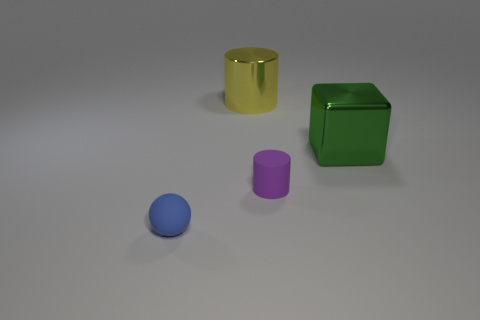Subtract 0 brown blocks. How many objects are left? 4 Subtract all cubes. How many objects are left? 3 Subtract all purple blocks. Subtract all blue balls. How many blocks are left? 1 Subtract all green balls. How many yellow cylinders are left? 1 Subtract all big red spheres. Subtract all tiny matte objects. How many objects are left? 2 Add 1 yellow metal objects. How many yellow metal objects are left? 2 Add 1 large cyan spheres. How many large cyan spheres exist? 1 Add 4 large yellow things. How many objects exist? 8 